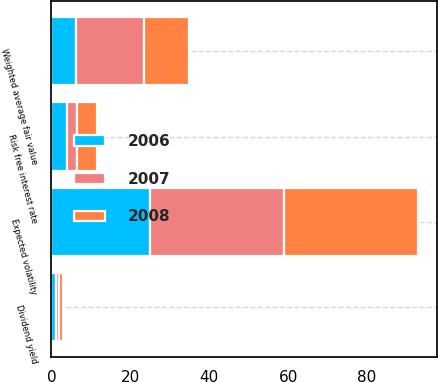Convert chart to OTSL. <chart><loc_0><loc_0><loc_500><loc_500><stacked_bar_chart><ecel><fcel>Dividend yield<fcel>Expected volatility<fcel>Risk free interest rate<fcel>Weighted average fair value<nl><fcel>2007<fcel>0.9<fcel>34<fcel>2.7<fcel>17.21<nl><fcel>2008<fcel>0.9<fcel>34<fcel>5<fcel>11.52<nl><fcel>2006<fcel>1.1<fcel>25<fcel>3.9<fcel>6.19<nl></chart> 